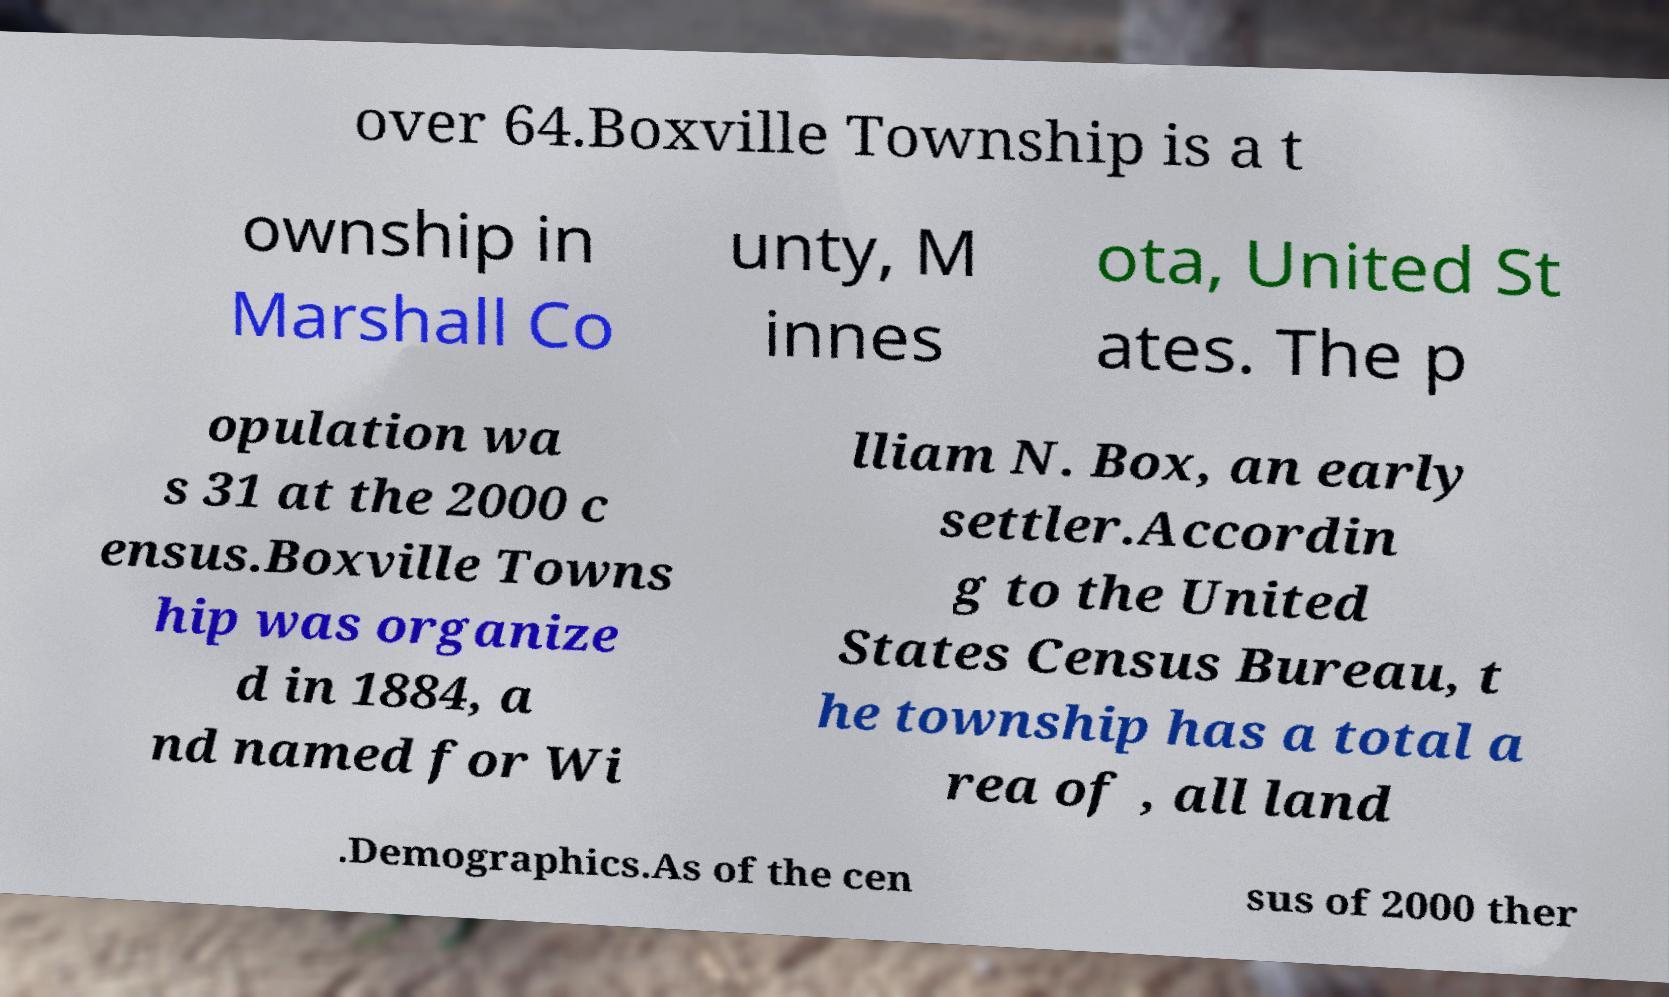Please identify and transcribe the text found in this image. over 64.Boxville Township is a t ownship in Marshall Co unty, M innes ota, United St ates. The p opulation wa s 31 at the 2000 c ensus.Boxville Towns hip was organize d in 1884, a nd named for Wi lliam N. Box, an early settler.Accordin g to the United States Census Bureau, t he township has a total a rea of , all land .Demographics.As of the cen sus of 2000 ther 